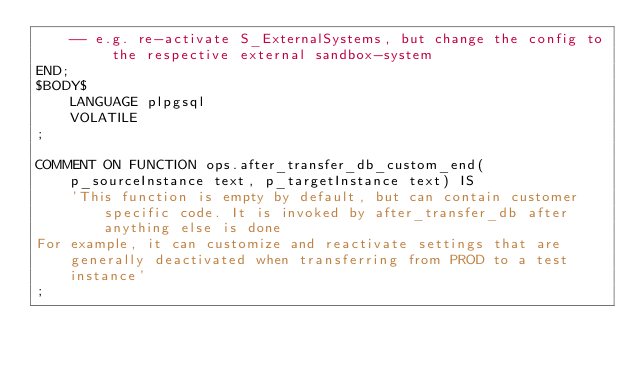<code> <loc_0><loc_0><loc_500><loc_500><_SQL_>    -- e.g. re-activate S_ExternalSystems, but change the config to the respective external sandbox-system
END;
$BODY$
    LANGUAGE plpgsql
    VOLATILE
;

COMMENT ON FUNCTION ops.after_transfer_db_custom_end(p_sourceInstance text, p_targetInstance text) IS
    'This function is empty by default, but can contain customer specific code. It is invoked by after_transfer_db after anything else is done
For example, it can customize and reactivate settings that are generally deactivated when transferring from PROD to a test instance'
;</code> 